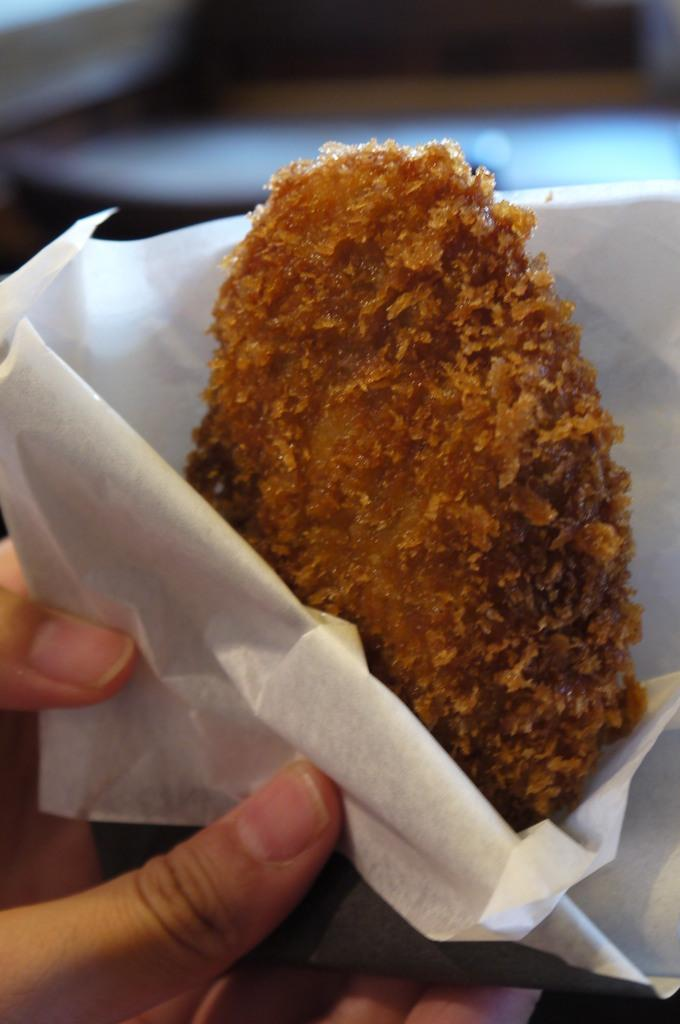What is being held by the hands in the image? There are hands holding a food item in the image. What else can be seen in the image besides the hands and food item? Tissue papers are present in the image. Can you describe the background of the image? The background of the image is blurred. What is the name of the street downtown that can be seen in the image? There is no street or downtown location visible in the image. How high can the person jump in the image? There is no person or jumping activity depicted in the image. 